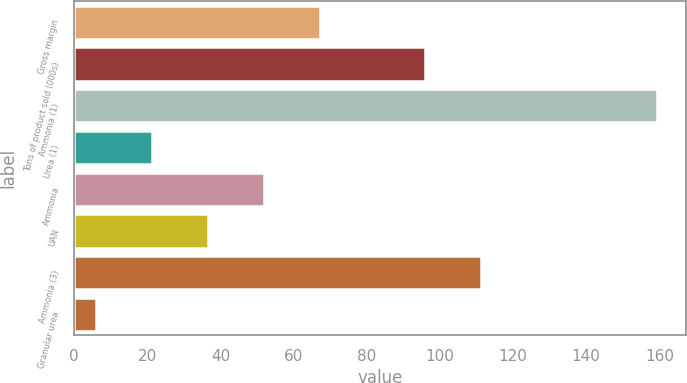<chart> <loc_0><loc_0><loc_500><loc_500><bar_chart><fcel>Gross margin<fcel>Tons of product sold (000s)<fcel>Ammonia (1)<fcel>Urea (1)<fcel>Ammonia<fcel>UAN<fcel>Ammonia (3)<fcel>Granular urea<nl><fcel>67.26<fcel>95.9<fcel>159.3<fcel>21.24<fcel>51.92<fcel>36.58<fcel>111.24<fcel>5.9<nl></chart> 